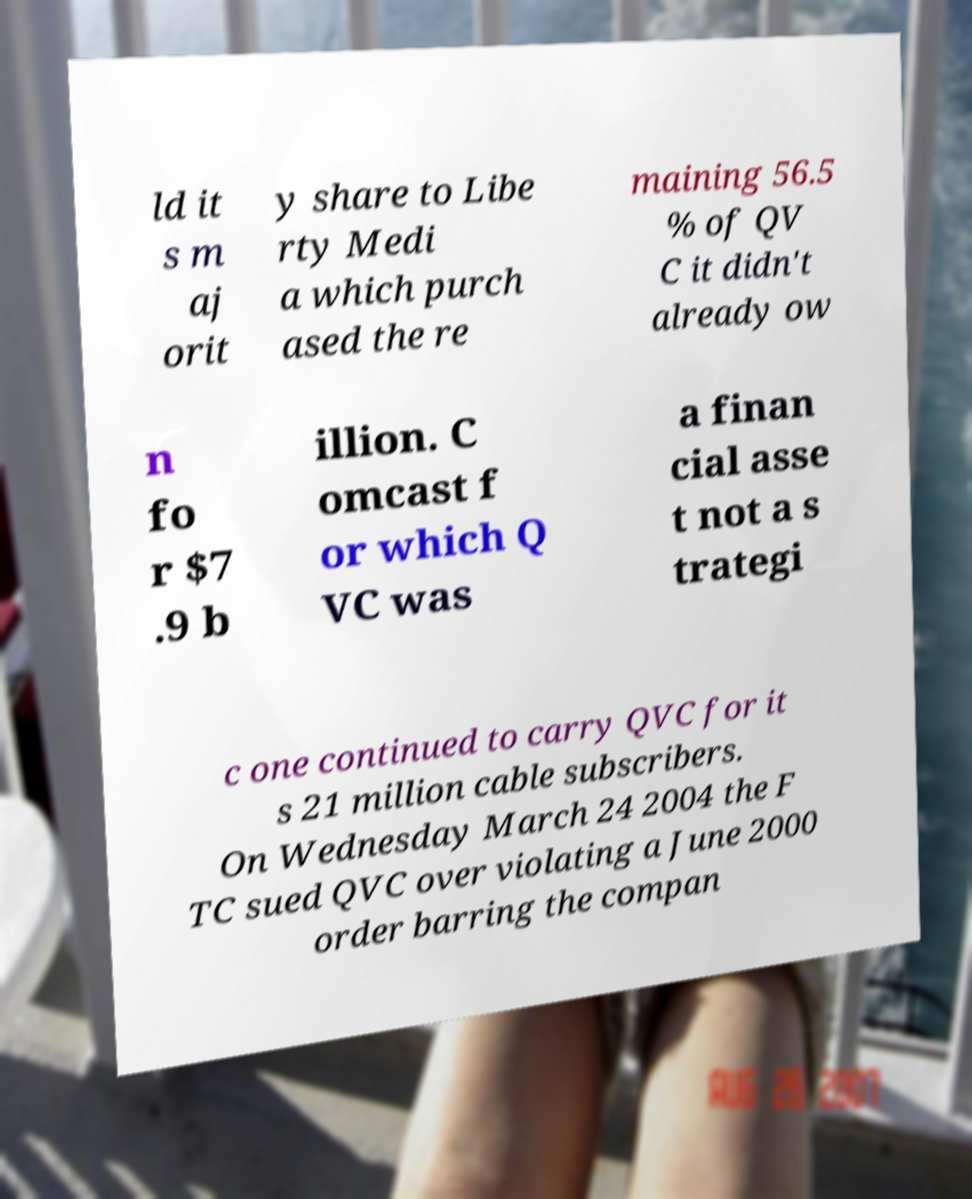Please identify and transcribe the text found in this image. ld it s m aj orit y share to Libe rty Medi a which purch ased the re maining 56.5 % of QV C it didn't already ow n fo r $7 .9 b illion. C omcast f or which Q VC was a finan cial asse t not a s trategi c one continued to carry QVC for it s 21 million cable subscribers. On Wednesday March 24 2004 the F TC sued QVC over violating a June 2000 order barring the compan 